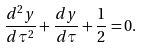<formula> <loc_0><loc_0><loc_500><loc_500>\frac { d ^ { 2 } y } { d \tau ^ { 2 } } + \frac { d y } { d \tau } + \frac { 1 } { 2 } = 0 .</formula> 